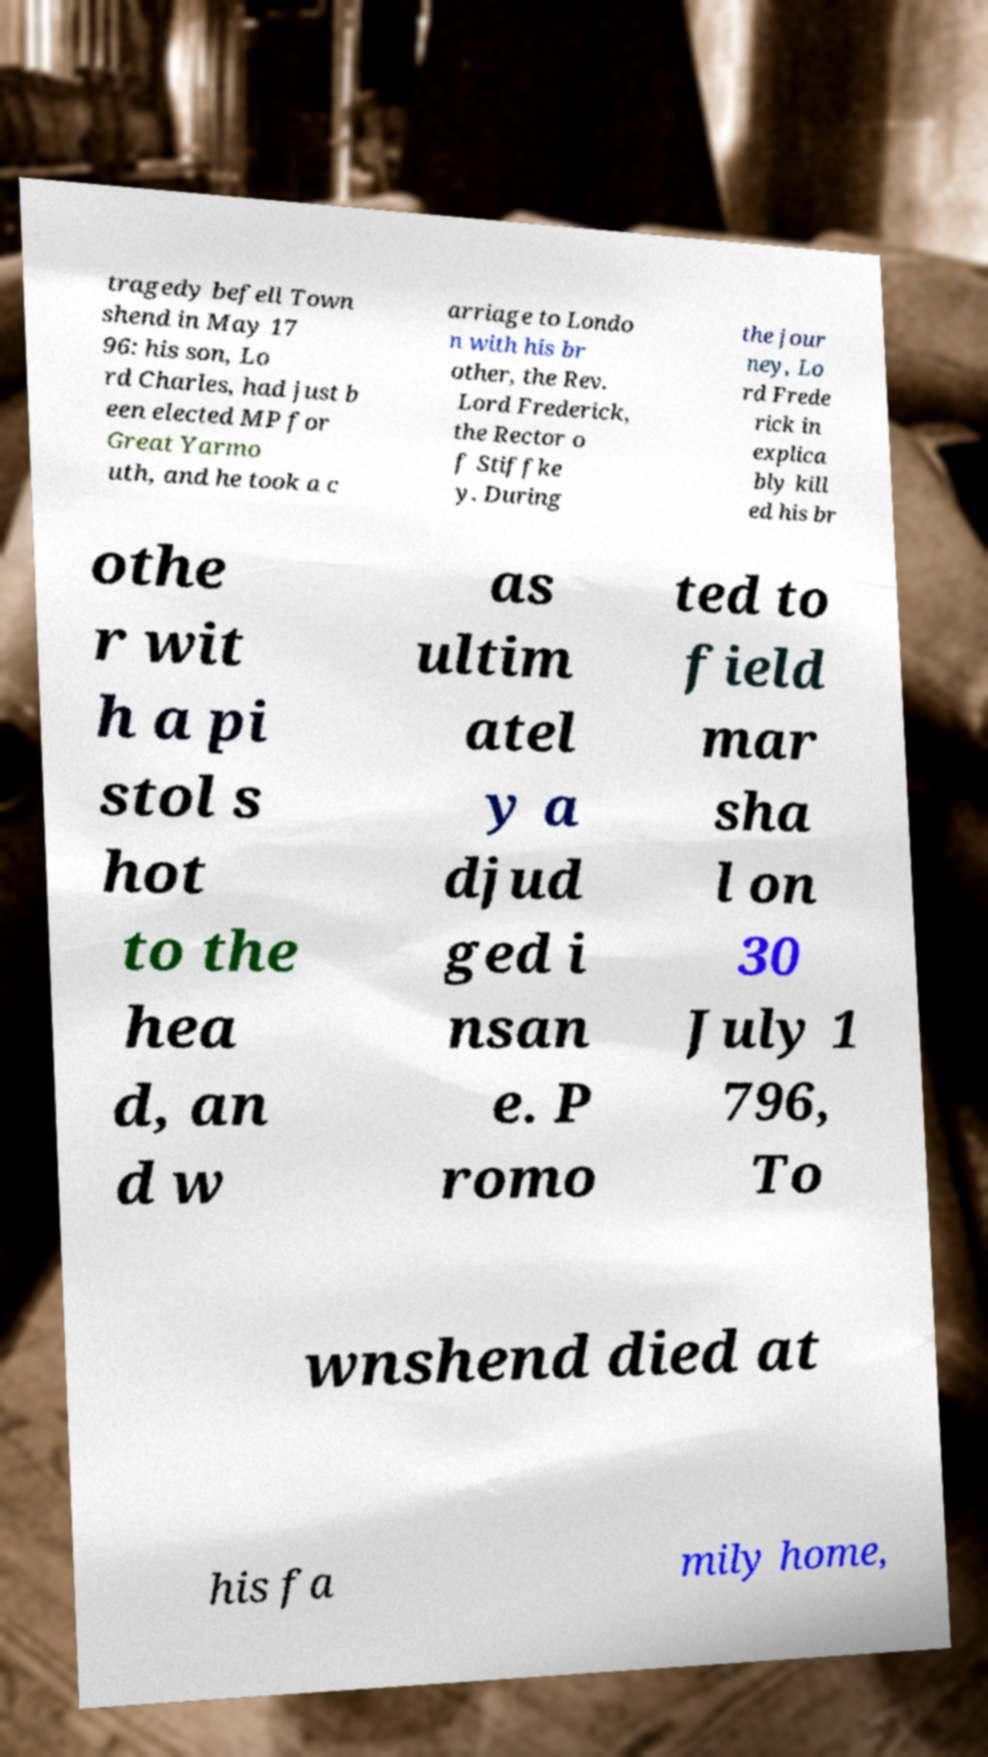Can you read and provide the text displayed in the image?This photo seems to have some interesting text. Can you extract and type it out for me? tragedy befell Town shend in May 17 96: his son, Lo rd Charles, had just b een elected MP for Great Yarmo uth, and he took a c arriage to Londo n with his br other, the Rev. Lord Frederick, the Rector o f Stiffke y. During the jour ney, Lo rd Frede rick in explica bly kill ed his br othe r wit h a pi stol s hot to the hea d, an d w as ultim atel y a djud ged i nsan e. P romo ted to field mar sha l on 30 July 1 796, To wnshend died at his fa mily home, 